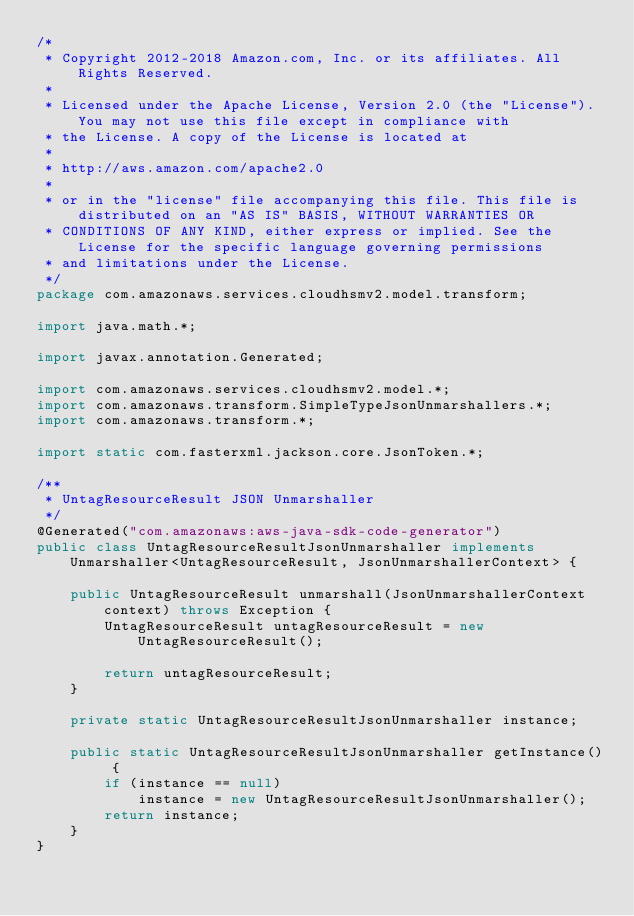<code> <loc_0><loc_0><loc_500><loc_500><_Java_>/*
 * Copyright 2012-2018 Amazon.com, Inc. or its affiliates. All Rights Reserved.
 * 
 * Licensed under the Apache License, Version 2.0 (the "License"). You may not use this file except in compliance with
 * the License. A copy of the License is located at
 * 
 * http://aws.amazon.com/apache2.0
 * 
 * or in the "license" file accompanying this file. This file is distributed on an "AS IS" BASIS, WITHOUT WARRANTIES OR
 * CONDITIONS OF ANY KIND, either express or implied. See the License for the specific language governing permissions
 * and limitations under the License.
 */
package com.amazonaws.services.cloudhsmv2.model.transform;

import java.math.*;

import javax.annotation.Generated;

import com.amazonaws.services.cloudhsmv2.model.*;
import com.amazonaws.transform.SimpleTypeJsonUnmarshallers.*;
import com.amazonaws.transform.*;

import static com.fasterxml.jackson.core.JsonToken.*;

/**
 * UntagResourceResult JSON Unmarshaller
 */
@Generated("com.amazonaws:aws-java-sdk-code-generator")
public class UntagResourceResultJsonUnmarshaller implements Unmarshaller<UntagResourceResult, JsonUnmarshallerContext> {

    public UntagResourceResult unmarshall(JsonUnmarshallerContext context) throws Exception {
        UntagResourceResult untagResourceResult = new UntagResourceResult();

        return untagResourceResult;
    }

    private static UntagResourceResultJsonUnmarshaller instance;

    public static UntagResourceResultJsonUnmarshaller getInstance() {
        if (instance == null)
            instance = new UntagResourceResultJsonUnmarshaller();
        return instance;
    }
}
</code> 